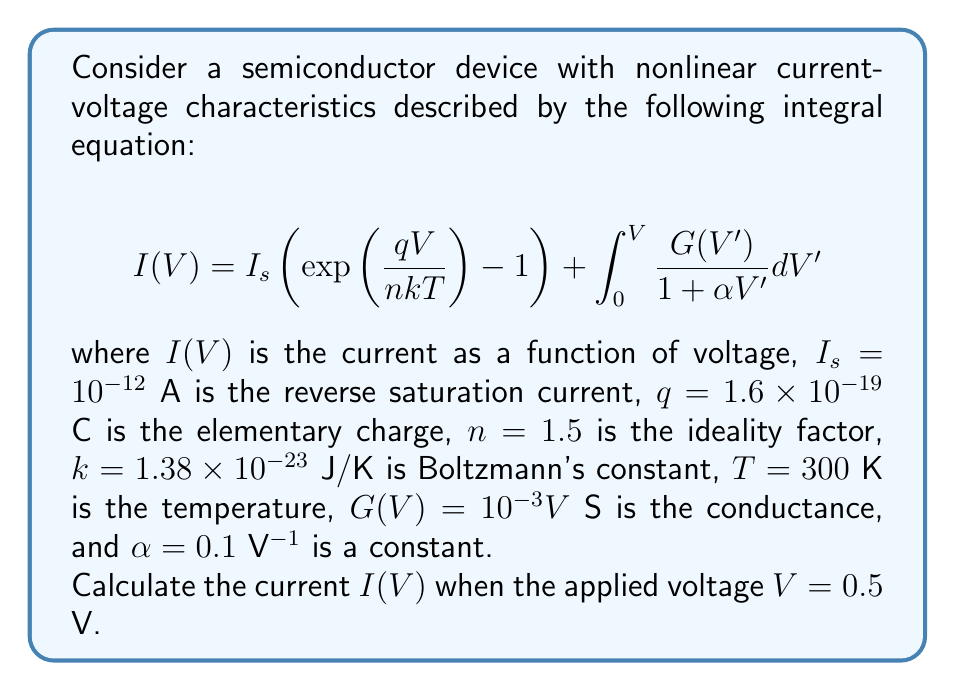Help me with this question. To solve this problem, we need to evaluate the integral equation for the given voltage. Let's break it down step-by-step:

1) First, let's calculate the exponential term:
   $$\frac{qV}{nkT} = \frac{(1.6 \times 10^{-19})(0.5)}{(1.5)(1.38 \times 10^{-23})(300)} \approx 12.82$$

2) Now, we can evaluate the first part of the equation:
   $$I_s \left(\exp\left(\frac{qV}{nkT}\right) - 1\right) = 10^{-12}(\exp(12.82) - 1) \approx 3.69 \times 10^{-7} \text{ A}$$

3) For the integral part, we need to solve:
   $$\int_0^V \frac{G(V')}{1 + \alpha V'} dV' = \int_0^{0.5} \frac{10^{-3}V'}{1 + 0.1V'} dV'$$

4) To solve this integral, we can use the substitution $u = 1 + 0.1V'$, which gives:
   $$\frac{1}{0.1} \int_1^{1.05} \frac{10^{-3}(u-1)}{u} du = 10^{-2} \int_1^{1.05} \left(1 - \frac{1}{u}\right) du$$

5) Evaluating this integral:
   $$10^{-2} \left[u - \ln(u)\right]_1^{1.05} = 10^{-2} [(1.05 - \ln(1.05)) - (1 - \ln(1))] \approx 4.88 \times 10^{-4} \text{ A}$$

6) The total current is the sum of both parts:
   $$I(V) = 3.69 \times 10^{-7} + 4.88 \times 10^{-4} \approx 4.88 \times 10^{-4} \text{ A}$$
Answer: $4.88 \times 10^{-4}$ A 